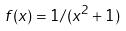Convert formula to latex. <formula><loc_0><loc_0><loc_500><loc_500>f ( x ) = 1 / ( x ^ { 2 } + 1 )</formula> 